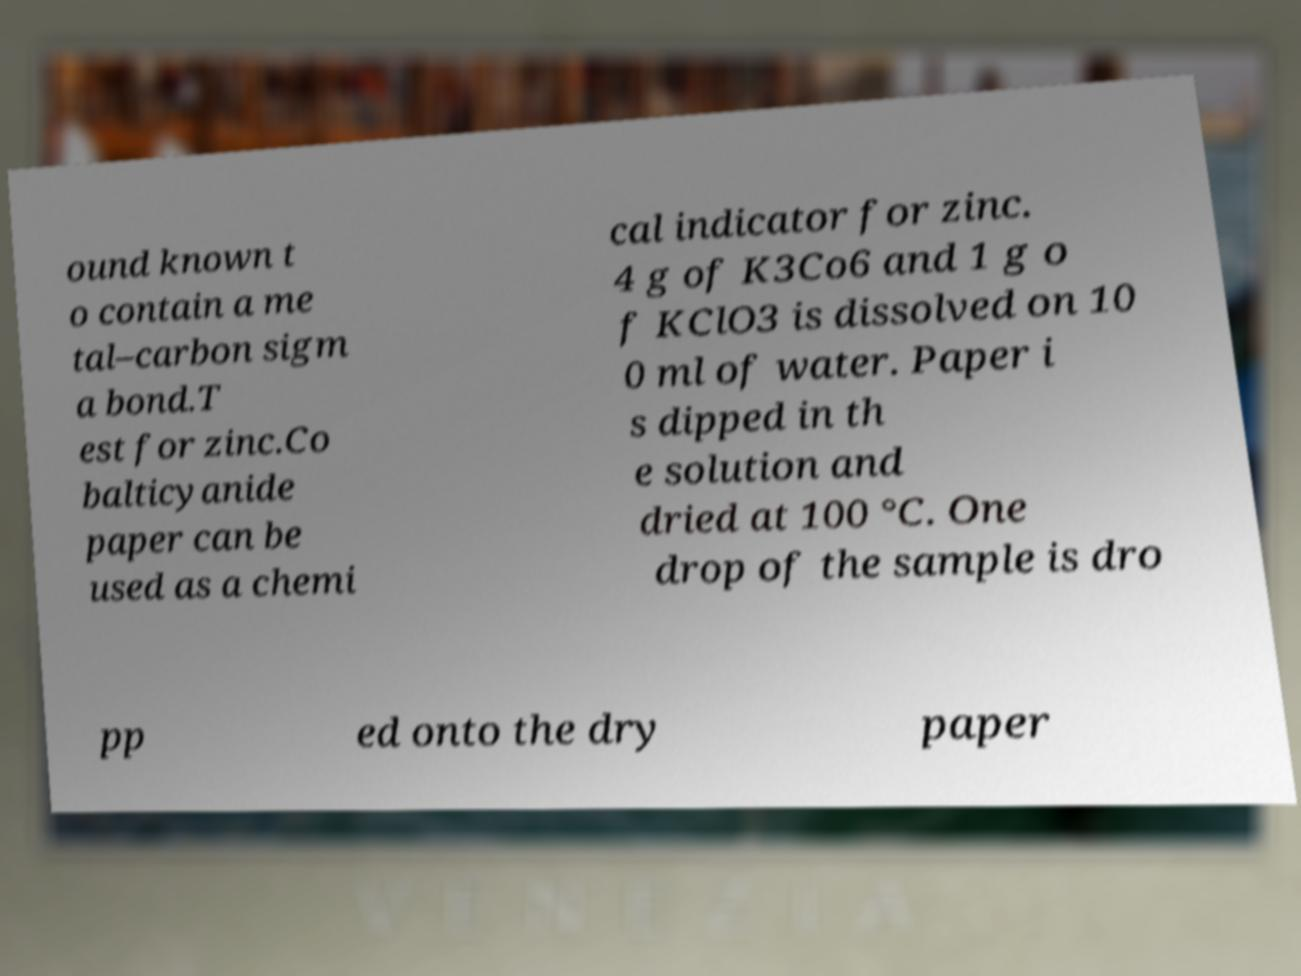Please read and relay the text visible in this image. What does it say? ound known t o contain a me tal–carbon sigm a bond.T est for zinc.Co balticyanide paper can be used as a chemi cal indicator for zinc. 4 g of K3Co6 and 1 g o f KClO3 is dissolved on 10 0 ml of water. Paper i s dipped in th e solution and dried at 100 °C. One drop of the sample is dro pp ed onto the dry paper 